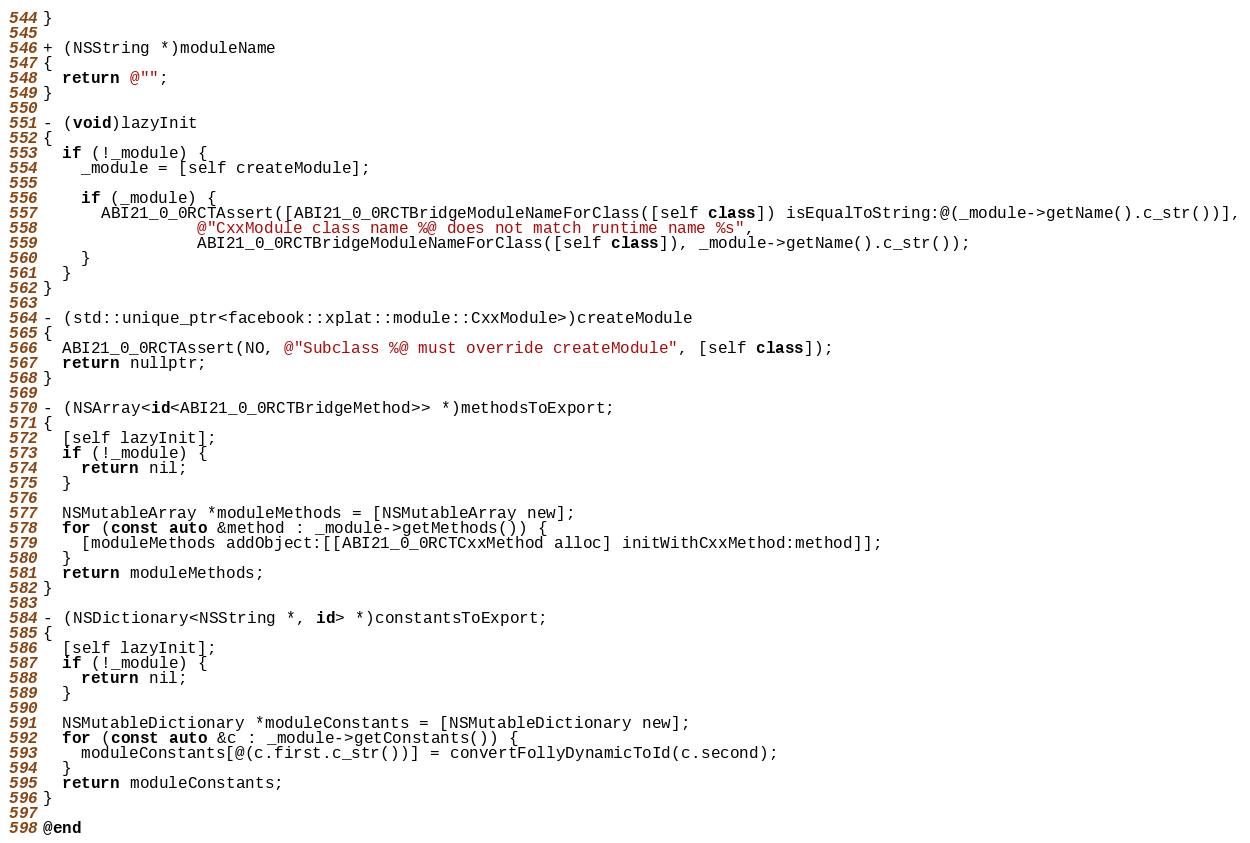<code> <loc_0><loc_0><loc_500><loc_500><_ObjectiveC_>}

+ (NSString *)moduleName
{
  return @"";
}

- (void)lazyInit
{
  if (!_module) {
    _module = [self createModule];

    if (_module) {
      ABI21_0_0RCTAssert([ABI21_0_0RCTBridgeModuleNameForClass([self class]) isEqualToString:@(_module->getName().c_str())],
                @"CxxModule class name %@ does not match runtime name %s",
                ABI21_0_0RCTBridgeModuleNameForClass([self class]), _module->getName().c_str());
    }
  }
}

- (std::unique_ptr<facebook::xplat::module::CxxModule>)createModule
{
  ABI21_0_0RCTAssert(NO, @"Subclass %@ must override createModule", [self class]);
  return nullptr;
}

- (NSArray<id<ABI21_0_0RCTBridgeMethod>> *)methodsToExport;
{
  [self lazyInit];
  if (!_module) {
    return nil;
  }

  NSMutableArray *moduleMethods = [NSMutableArray new];
  for (const auto &method : _module->getMethods()) {
    [moduleMethods addObject:[[ABI21_0_0RCTCxxMethod alloc] initWithCxxMethod:method]];
  }
  return moduleMethods;
}

- (NSDictionary<NSString *, id> *)constantsToExport;
{
  [self lazyInit];
  if (!_module) {
    return nil;
  }

  NSMutableDictionary *moduleConstants = [NSMutableDictionary new];
  for (const auto &c : _module->getConstants()) {
    moduleConstants[@(c.first.c_str())] = convertFollyDynamicToId(c.second);
  }
  return moduleConstants;
}

@end
</code> 